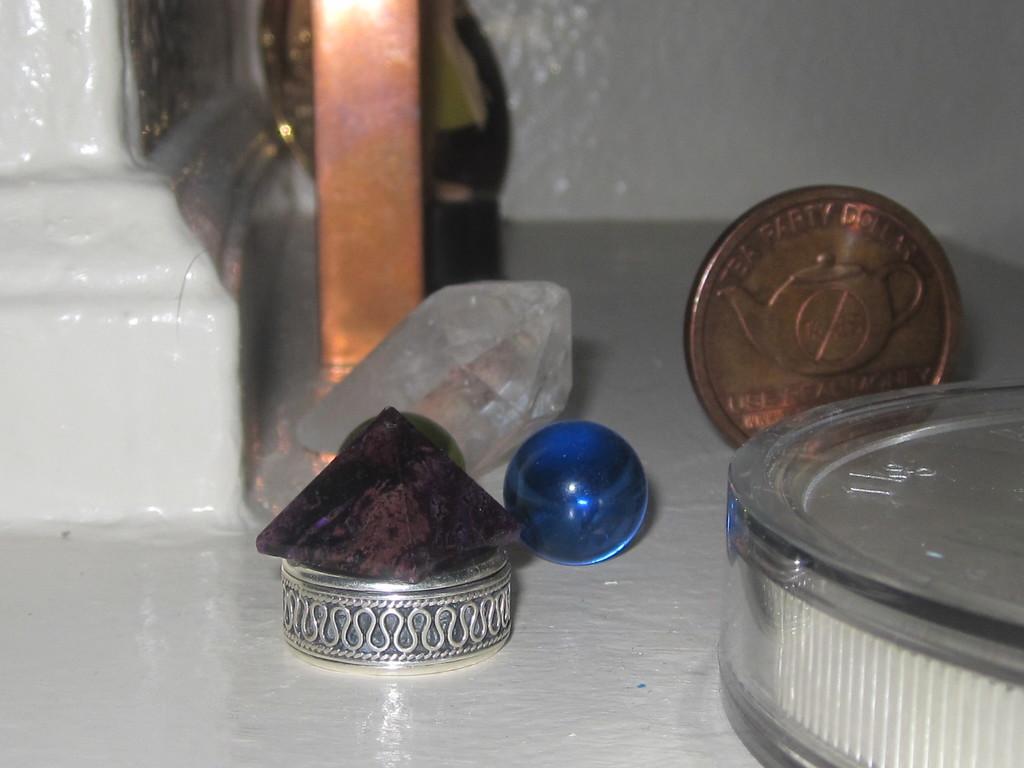What type of party is mentioned on the coin in the back?
Your answer should be compact. Tea party. 